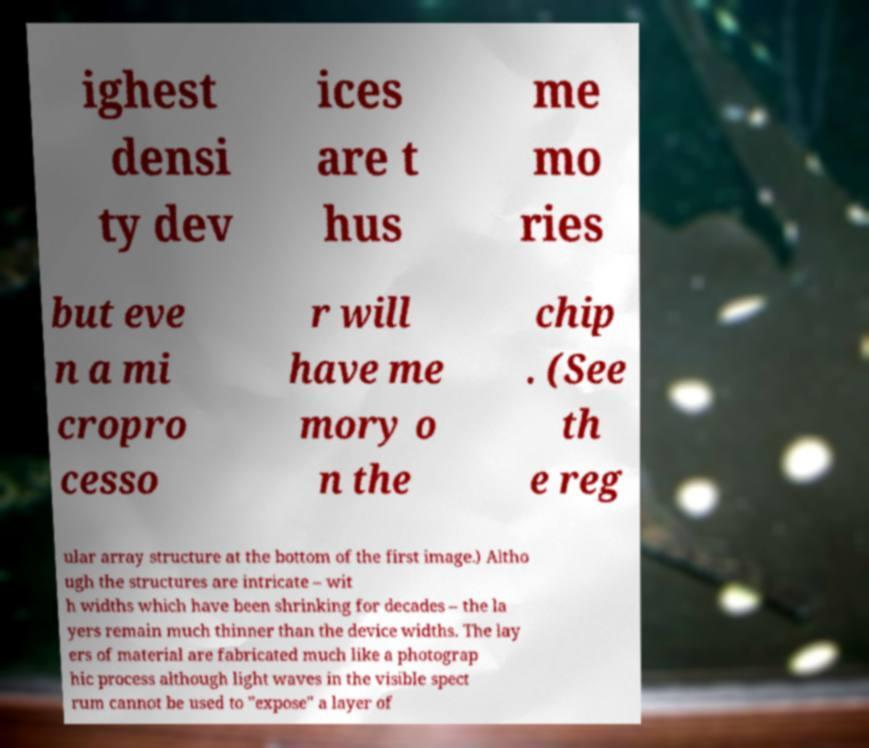Can you read and provide the text displayed in the image?This photo seems to have some interesting text. Can you extract and type it out for me? ighest densi ty dev ices are t hus me mo ries but eve n a mi cropro cesso r will have me mory o n the chip . (See th e reg ular array structure at the bottom of the first image.) Altho ugh the structures are intricate – wit h widths which have been shrinking for decades – the la yers remain much thinner than the device widths. The lay ers of material are fabricated much like a photograp hic process although light waves in the visible spect rum cannot be used to "expose" a layer of 